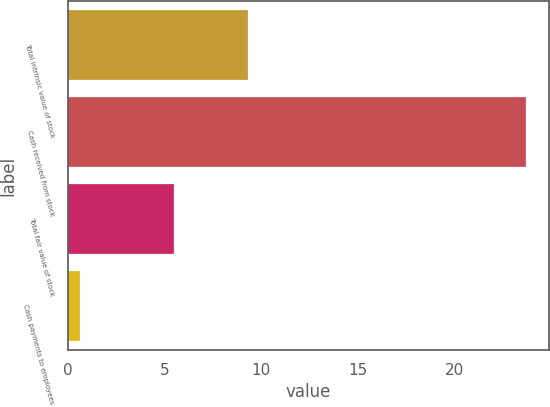Convert chart. <chart><loc_0><loc_0><loc_500><loc_500><bar_chart><fcel>Total intrinsic value of stock<fcel>Cash received from stock<fcel>Total fair value of stock<fcel>Cash payments to employees<nl><fcel>9.3<fcel>23.7<fcel>5.5<fcel>0.6<nl></chart> 